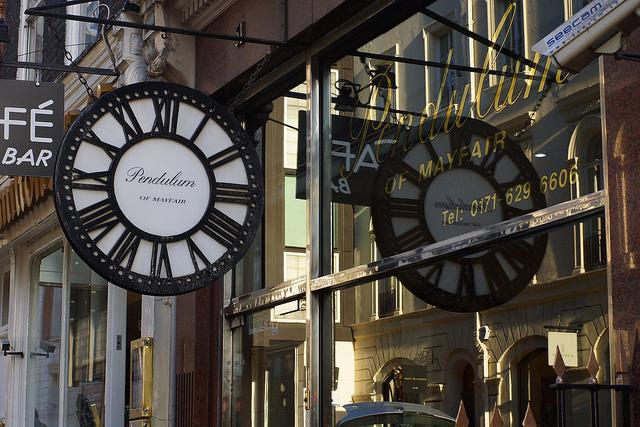Is the clock in front of a church?
Write a very short answer. No. Does the clock have hands?
Quick response, please. No. Is the telephone number listed for the business?
Give a very brief answer. Yes. 